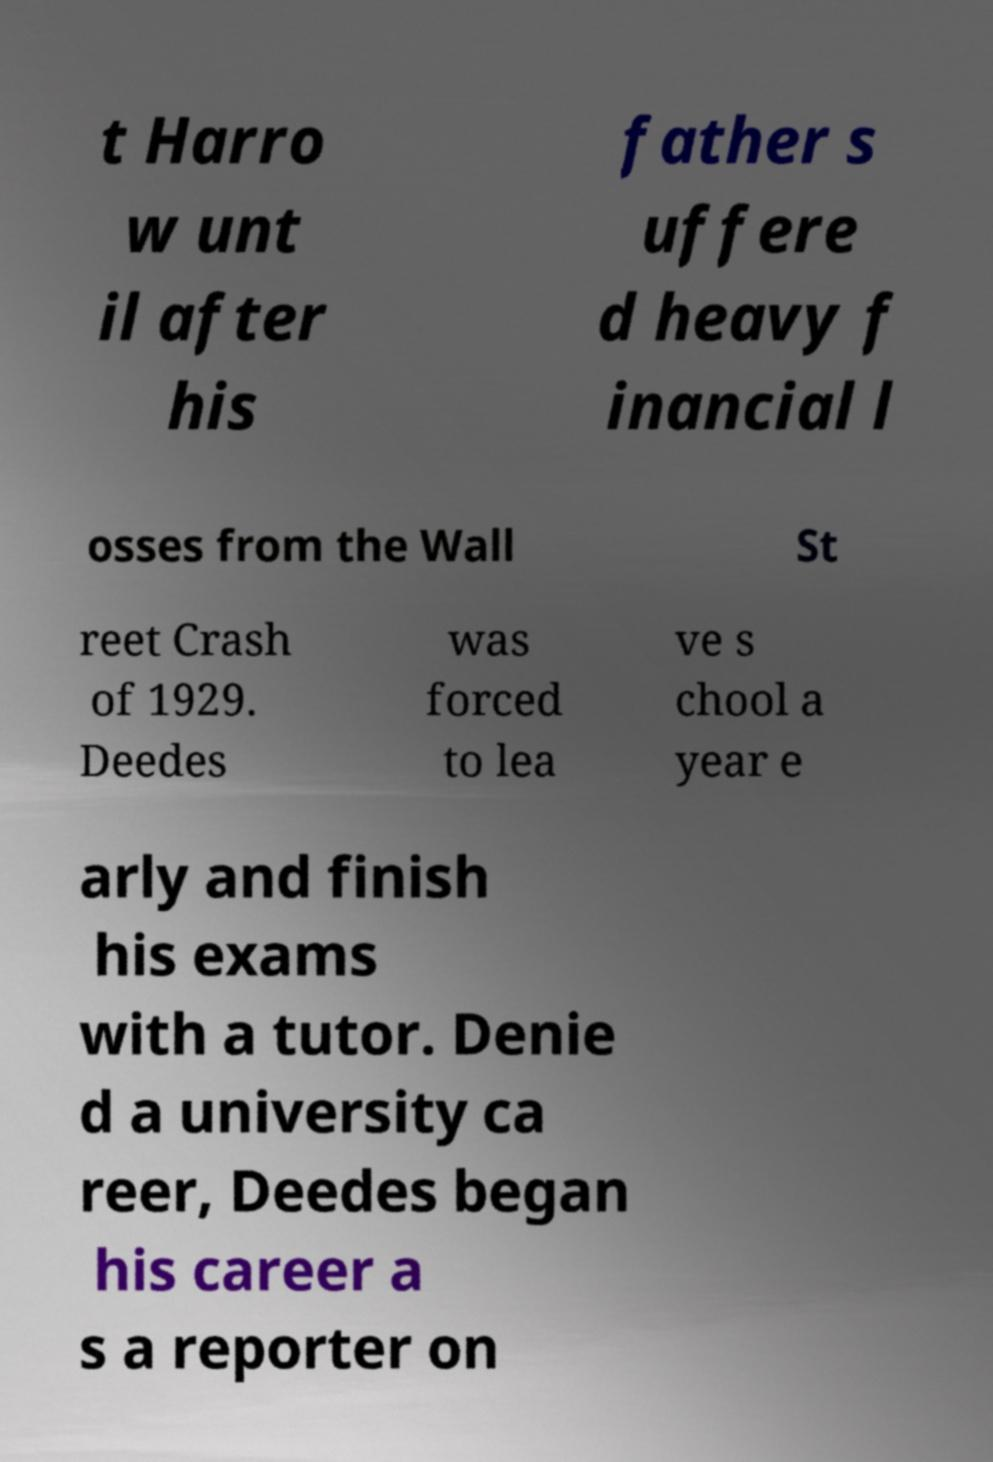There's text embedded in this image that I need extracted. Can you transcribe it verbatim? t Harro w unt il after his father s uffere d heavy f inancial l osses from the Wall St reet Crash of 1929. Deedes was forced to lea ve s chool a year e arly and finish his exams with a tutor. Denie d a university ca reer, Deedes began his career a s a reporter on 